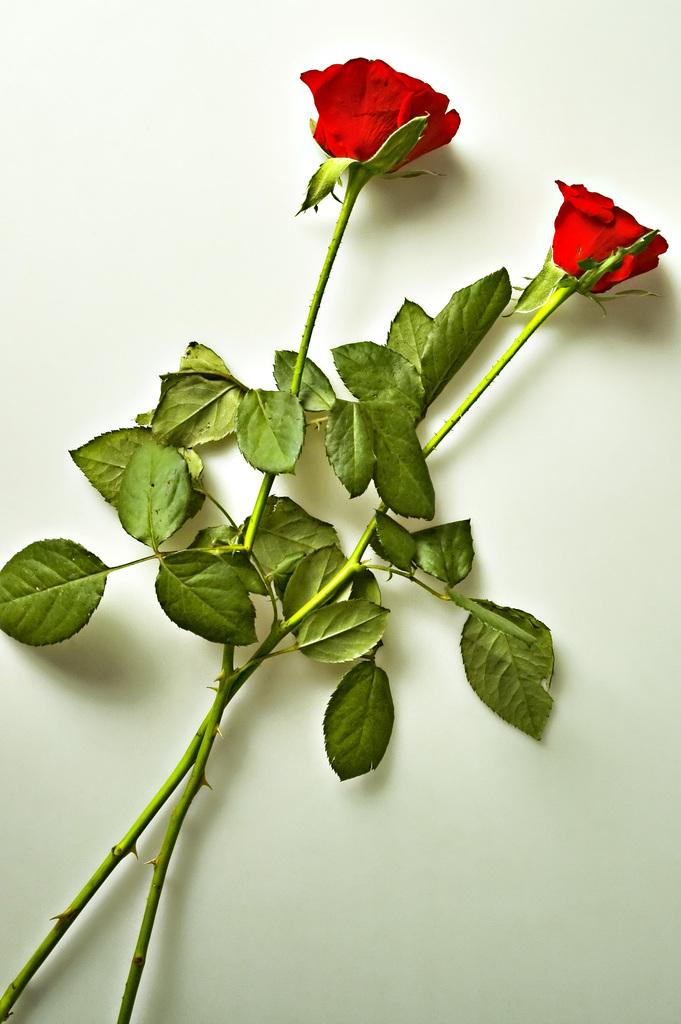What type of flowers are in the image? There are two red roses in the image. What parts of the roses are visible in the image? The roses have stems and leaves in the image. Where are the roses placed in the image? The roses are on a platform in the image. Can you see a goose attempting to climb the platform in the image? No, there is no goose or any attempt to climb the platform in the image. What type of linen is draped over the platform in the image? There is no linen visible in the image; it only features the two red roses on a platform. 